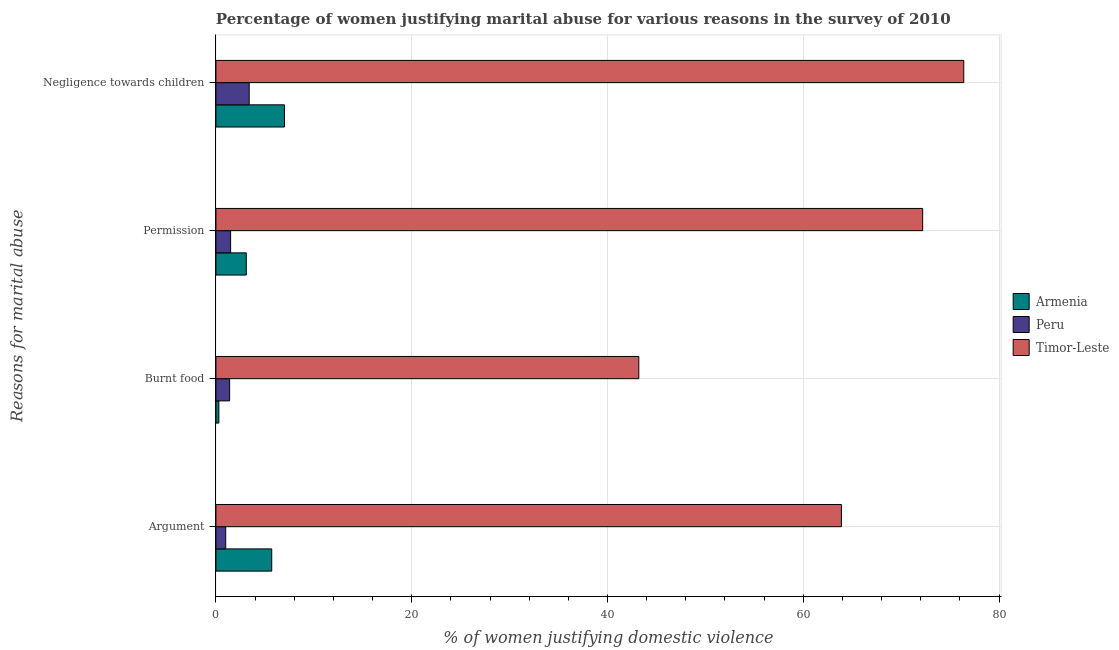How many different coloured bars are there?
Give a very brief answer. 3. Are the number of bars per tick equal to the number of legend labels?
Offer a terse response. Yes. How many bars are there on the 2nd tick from the top?
Provide a succinct answer. 3. How many bars are there on the 1st tick from the bottom?
Offer a very short reply. 3. What is the label of the 4th group of bars from the top?
Offer a terse response. Argument. Across all countries, what is the maximum percentage of women justifying abuse in the case of an argument?
Your answer should be compact. 63.9. Across all countries, what is the minimum percentage of women justifying abuse for showing negligence towards children?
Offer a terse response. 3.4. In which country was the percentage of women justifying abuse for going without permission maximum?
Provide a succinct answer. Timor-Leste. In which country was the percentage of women justifying abuse for burning food minimum?
Keep it short and to the point. Armenia. What is the total percentage of women justifying abuse for showing negligence towards children in the graph?
Make the answer very short. 86.8. What is the difference between the percentage of women justifying abuse for burning food in Timor-Leste and that in Peru?
Your answer should be very brief. 41.8. What is the difference between the percentage of women justifying abuse for going without permission in Peru and the percentage of women justifying abuse in the case of an argument in Timor-Leste?
Your answer should be very brief. -62.4. What is the average percentage of women justifying abuse for burning food per country?
Ensure brevity in your answer.  14.97. What is the difference between the percentage of women justifying abuse for going without permission and percentage of women justifying abuse for burning food in Peru?
Provide a succinct answer. 0.1. What is the ratio of the percentage of women justifying abuse for going without permission in Peru to that in Timor-Leste?
Offer a terse response. 0.02. What is the difference between the highest and the second highest percentage of women justifying abuse for going without permission?
Your answer should be very brief. 69.1. What is the difference between the highest and the lowest percentage of women justifying abuse for burning food?
Your answer should be compact. 42.9. In how many countries, is the percentage of women justifying abuse for showing negligence towards children greater than the average percentage of women justifying abuse for showing negligence towards children taken over all countries?
Your answer should be very brief. 1. Is the sum of the percentage of women justifying abuse for showing negligence towards children in Armenia and Peru greater than the maximum percentage of women justifying abuse for burning food across all countries?
Offer a very short reply. No. What does the 1st bar from the top in Negligence towards children represents?
Keep it short and to the point. Timor-Leste. What does the 2nd bar from the bottom in Negligence towards children represents?
Keep it short and to the point. Peru. Is it the case that in every country, the sum of the percentage of women justifying abuse in the case of an argument and percentage of women justifying abuse for burning food is greater than the percentage of women justifying abuse for going without permission?
Your response must be concise. Yes. How many bars are there?
Your answer should be very brief. 12. What is the difference between two consecutive major ticks on the X-axis?
Your response must be concise. 20. Are the values on the major ticks of X-axis written in scientific E-notation?
Provide a succinct answer. No. How are the legend labels stacked?
Ensure brevity in your answer.  Vertical. What is the title of the graph?
Provide a short and direct response. Percentage of women justifying marital abuse for various reasons in the survey of 2010. What is the label or title of the X-axis?
Make the answer very short. % of women justifying domestic violence. What is the label or title of the Y-axis?
Your answer should be compact. Reasons for marital abuse. What is the % of women justifying domestic violence of Timor-Leste in Argument?
Your answer should be very brief. 63.9. What is the % of women justifying domestic violence of Armenia in Burnt food?
Offer a terse response. 0.3. What is the % of women justifying domestic violence of Timor-Leste in Burnt food?
Ensure brevity in your answer.  43.2. What is the % of women justifying domestic violence of Armenia in Permission?
Keep it short and to the point. 3.1. What is the % of women justifying domestic violence in Peru in Permission?
Provide a succinct answer. 1.5. What is the % of women justifying domestic violence in Timor-Leste in Permission?
Make the answer very short. 72.2. What is the % of women justifying domestic violence in Timor-Leste in Negligence towards children?
Provide a short and direct response. 76.4. Across all Reasons for marital abuse, what is the maximum % of women justifying domestic violence of Armenia?
Keep it short and to the point. 7. Across all Reasons for marital abuse, what is the maximum % of women justifying domestic violence in Peru?
Make the answer very short. 3.4. Across all Reasons for marital abuse, what is the maximum % of women justifying domestic violence of Timor-Leste?
Give a very brief answer. 76.4. Across all Reasons for marital abuse, what is the minimum % of women justifying domestic violence of Armenia?
Your response must be concise. 0.3. Across all Reasons for marital abuse, what is the minimum % of women justifying domestic violence of Timor-Leste?
Give a very brief answer. 43.2. What is the total % of women justifying domestic violence in Peru in the graph?
Your response must be concise. 7.3. What is the total % of women justifying domestic violence in Timor-Leste in the graph?
Provide a succinct answer. 255.7. What is the difference between the % of women justifying domestic violence in Armenia in Argument and that in Burnt food?
Ensure brevity in your answer.  5.4. What is the difference between the % of women justifying domestic violence of Peru in Argument and that in Burnt food?
Provide a short and direct response. -0.4. What is the difference between the % of women justifying domestic violence in Timor-Leste in Argument and that in Burnt food?
Provide a succinct answer. 20.7. What is the difference between the % of women justifying domestic violence in Peru in Argument and that in Permission?
Provide a succinct answer. -0.5. What is the difference between the % of women justifying domestic violence of Timor-Leste in Argument and that in Permission?
Offer a very short reply. -8.3. What is the difference between the % of women justifying domestic violence of Peru in Argument and that in Negligence towards children?
Give a very brief answer. -2.4. What is the difference between the % of women justifying domestic violence in Timor-Leste in Argument and that in Negligence towards children?
Your answer should be very brief. -12.5. What is the difference between the % of women justifying domestic violence in Armenia in Burnt food and that in Permission?
Your answer should be compact. -2.8. What is the difference between the % of women justifying domestic violence in Peru in Burnt food and that in Permission?
Offer a terse response. -0.1. What is the difference between the % of women justifying domestic violence of Armenia in Burnt food and that in Negligence towards children?
Ensure brevity in your answer.  -6.7. What is the difference between the % of women justifying domestic violence of Peru in Burnt food and that in Negligence towards children?
Offer a very short reply. -2. What is the difference between the % of women justifying domestic violence of Timor-Leste in Burnt food and that in Negligence towards children?
Provide a succinct answer. -33.2. What is the difference between the % of women justifying domestic violence in Peru in Permission and that in Negligence towards children?
Provide a short and direct response. -1.9. What is the difference between the % of women justifying domestic violence in Armenia in Argument and the % of women justifying domestic violence in Timor-Leste in Burnt food?
Keep it short and to the point. -37.5. What is the difference between the % of women justifying domestic violence in Peru in Argument and the % of women justifying domestic violence in Timor-Leste in Burnt food?
Provide a short and direct response. -42.2. What is the difference between the % of women justifying domestic violence of Armenia in Argument and the % of women justifying domestic violence of Timor-Leste in Permission?
Provide a short and direct response. -66.5. What is the difference between the % of women justifying domestic violence in Peru in Argument and the % of women justifying domestic violence in Timor-Leste in Permission?
Give a very brief answer. -71.2. What is the difference between the % of women justifying domestic violence of Armenia in Argument and the % of women justifying domestic violence of Timor-Leste in Negligence towards children?
Give a very brief answer. -70.7. What is the difference between the % of women justifying domestic violence of Peru in Argument and the % of women justifying domestic violence of Timor-Leste in Negligence towards children?
Offer a very short reply. -75.4. What is the difference between the % of women justifying domestic violence of Armenia in Burnt food and the % of women justifying domestic violence of Timor-Leste in Permission?
Your response must be concise. -71.9. What is the difference between the % of women justifying domestic violence of Peru in Burnt food and the % of women justifying domestic violence of Timor-Leste in Permission?
Your answer should be very brief. -70.8. What is the difference between the % of women justifying domestic violence in Armenia in Burnt food and the % of women justifying domestic violence in Peru in Negligence towards children?
Offer a terse response. -3.1. What is the difference between the % of women justifying domestic violence in Armenia in Burnt food and the % of women justifying domestic violence in Timor-Leste in Negligence towards children?
Provide a succinct answer. -76.1. What is the difference between the % of women justifying domestic violence in Peru in Burnt food and the % of women justifying domestic violence in Timor-Leste in Negligence towards children?
Ensure brevity in your answer.  -75. What is the difference between the % of women justifying domestic violence in Armenia in Permission and the % of women justifying domestic violence in Timor-Leste in Negligence towards children?
Offer a terse response. -73.3. What is the difference between the % of women justifying domestic violence of Peru in Permission and the % of women justifying domestic violence of Timor-Leste in Negligence towards children?
Provide a short and direct response. -74.9. What is the average % of women justifying domestic violence in Armenia per Reasons for marital abuse?
Your response must be concise. 4.03. What is the average % of women justifying domestic violence of Peru per Reasons for marital abuse?
Keep it short and to the point. 1.82. What is the average % of women justifying domestic violence of Timor-Leste per Reasons for marital abuse?
Provide a succinct answer. 63.92. What is the difference between the % of women justifying domestic violence of Armenia and % of women justifying domestic violence of Peru in Argument?
Offer a very short reply. 4.7. What is the difference between the % of women justifying domestic violence in Armenia and % of women justifying domestic violence in Timor-Leste in Argument?
Ensure brevity in your answer.  -58.2. What is the difference between the % of women justifying domestic violence in Peru and % of women justifying domestic violence in Timor-Leste in Argument?
Your response must be concise. -62.9. What is the difference between the % of women justifying domestic violence of Armenia and % of women justifying domestic violence of Peru in Burnt food?
Provide a succinct answer. -1.1. What is the difference between the % of women justifying domestic violence of Armenia and % of women justifying domestic violence of Timor-Leste in Burnt food?
Your response must be concise. -42.9. What is the difference between the % of women justifying domestic violence of Peru and % of women justifying domestic violence of Timor-Leste in Burnt food?
Your response must be concise. -41.8. What is the difference between the % of women justifying domestic violence of Armenia and % of women justifying domestic violence of Peru in Permission?
Give a very brief answer. 1.6. What is the difference between the % of women justifying domestic violence in Armenia and % of women justifying domestic violence in Timor-Leste in Permission?
Your answer should be compact. -69.1. What is the difference between the % of women justifying domestic violence of Peru and % of women justifying domestic violence of Timor-Leste in Permission?
Provide a short and direct response. -70.7. What is the difference between the % of women justifying domestic violence in Armenia and % of women justifying domestic violence in Peru in Negligence towards children?
Ensure brevity in your answer.  3.6. What is the difference between the % of women justifying domestic violence of Armenia and % of women justifying domestic violence of Timor-Leste in Negligence towards children?
Offer a terse response. -69.4. What is the difference between the % of women justifying domestic violence in Peru and % of women justifying domestic violence in Timor-Leste in Negligence towards children?
Provide a succinct answer. -73. What is the ratio of the % of women justifying domestic violence in Armenia in Argument to that in Burnt food?
Offer a terse response. 19. What is the ratio of the % of women justifying domestic violence of Peru in Argument to that in Burnt food?
Keep it short and to the point. 0.71. What is the ratio of the % of women justifying domestic violence in Timor-Leste in Argument to that in Burnt food?
Provide a short and direct response. 1.48. What is the ratio of the % of women justifying domestic violence of Armenia in Argument to that in Permission?
Make the answer very short. 1.84. What is the ratio of the % of women justifying domestic violence in Peru in Argument to that in Permission?
Give a very brief answer. 0.67. What is the ratio of the % of women justifying domestic violence of Timor-Leste in Argument to that in Permission?
Provide a short and direct response. 0.89. What is the ratio of the % of women justifying domestic violence in Armenia in Argument to that in Negligence towards children?
Provide a succinct answer. 0.81. What is the ratio of the % of women justifying domestic violence in Peru in Argument to that in Negligence towards children?
Your response must be concise. 0.29. What is the ratio of the % of women justifying domestic violence of Timor-Leste in Argument to that in Negligence towards children?
Provide a short and direct response. 0.84. What is the ratio of the % of women justifying domestic violence in Armenia in Burnt food to that in Permission?
Give a very brief answer. 0.1. What is the ratio of the % of women justifying domestic violence of Timor-Leste in Burnt food to that in Permission?
Offer a very short reply. 0.6. What is the ratio of the % of women justifying domestic violence in Armenia in Burnt food to that in Negligence towards children?
Keep it short and to the point. 0.04. What is the ratio of the % of women justifying domestic violence of Peru in Burnt food to that in Negligence towards children?
Keep it short and to the point. 0.41. What is the ratio of the % of women justifying domestic violence in Timor-Leste in Burnt food to that in Negligence towards children?
Your answer should be compact. 0.57. What is the ratio of the % of women justifying domestic violence of Armenia in Permission to that in Negligence towards children?
Provide a succinct answer. 0.44. What is the ratio of the % of women justifying domestic violence in Peru in Permission to that in Negligence towards children?
Make the answer very short. 0.44. What is the ratio of the % of women justifying domestic violence of Timor-Leste in Permission to that in Negligence towards children?
Ensure brevity in your answer.  0.94. What is the difference between the highest and the second highest % of women justifying domestic violence of Timor-Leste?
Provide a succinct answer. 4.2. What is the difference between the highest and the lowest % of women justifying domestic violence in Armenia?
Ensure brevity in your answer.  6.7. What is the difference between the highest and the lowest % of women justifying domestic violence in Timor-Leste?
Offer a very short reply. 33.2. 